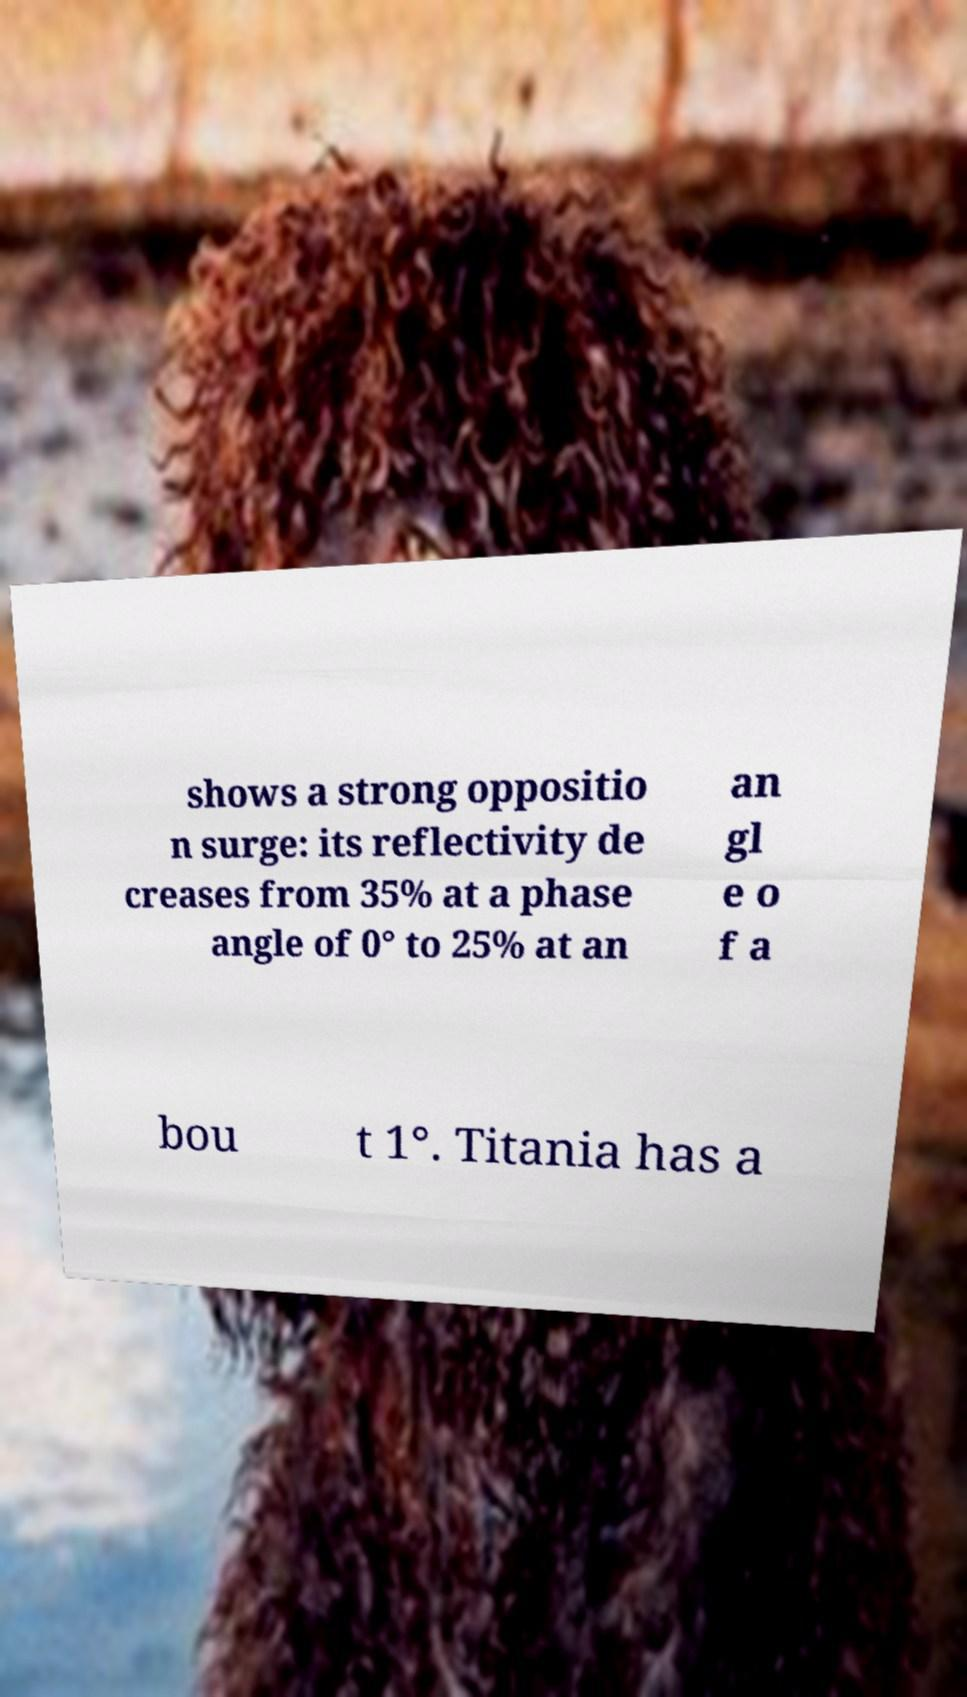What messages or text are displayed in this image? I need them in a readable, typed format. shows a strong oppositio n surge: its reflectivity de creases from 35% at a phase angle of 0° to 25% at an an gl e o f a bou t 1°. Titania has a 